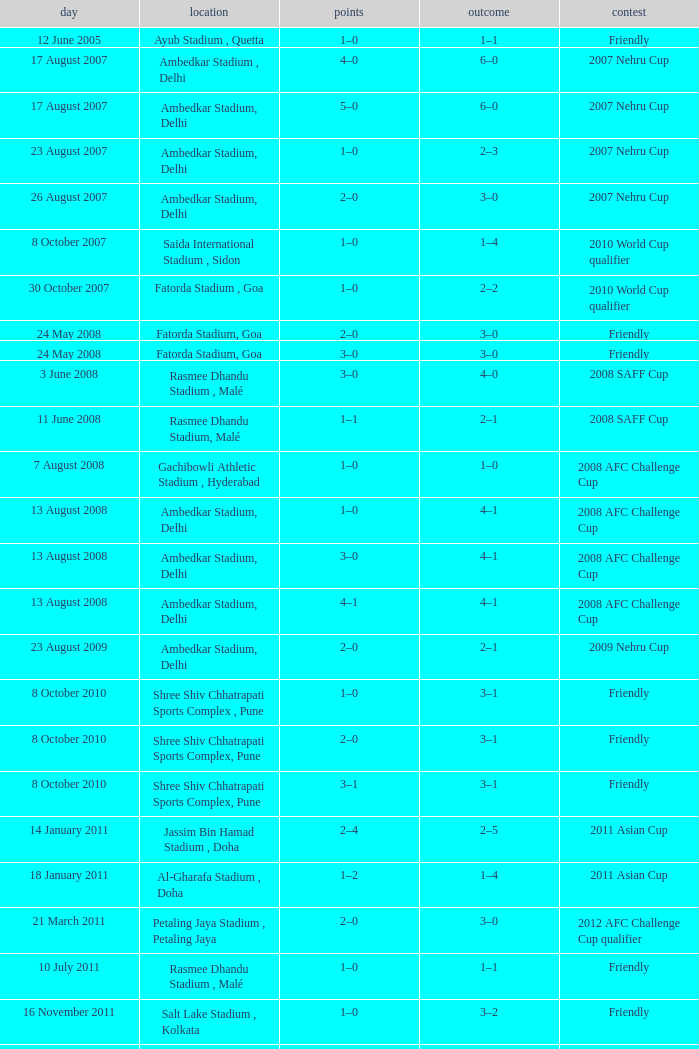Tell me the score on 22 august 2012 1–0. 